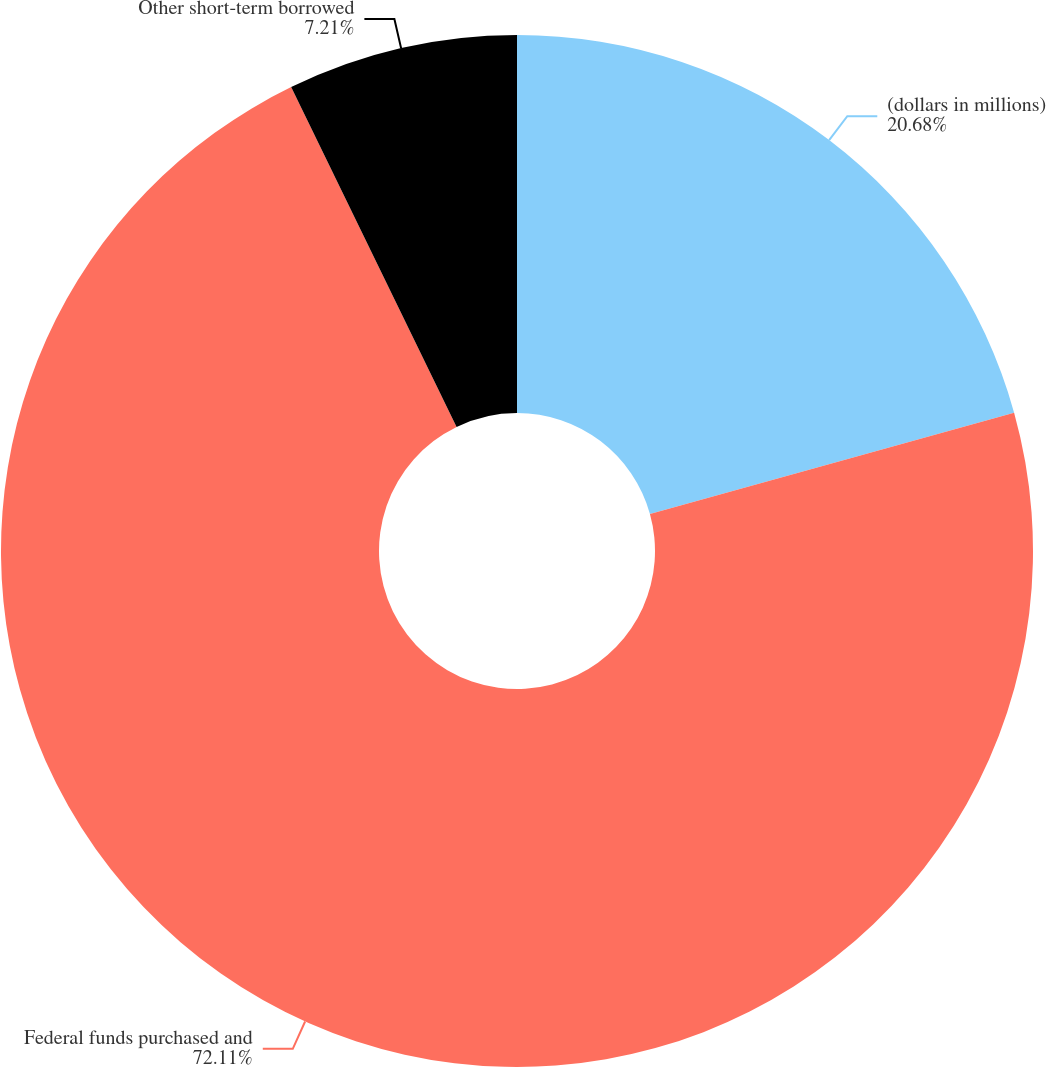Convert chart to OTSL. <chart><loc_0><loc_0><loc_500><loc_500><pie_chart><fcel>(dollars in millions)<fcel>Federal funds purchased and<fcel>Other short-term borrowed<nl><fcel>20.68%<fcel>72.11%<fcel>7.21%<nl></chart> 